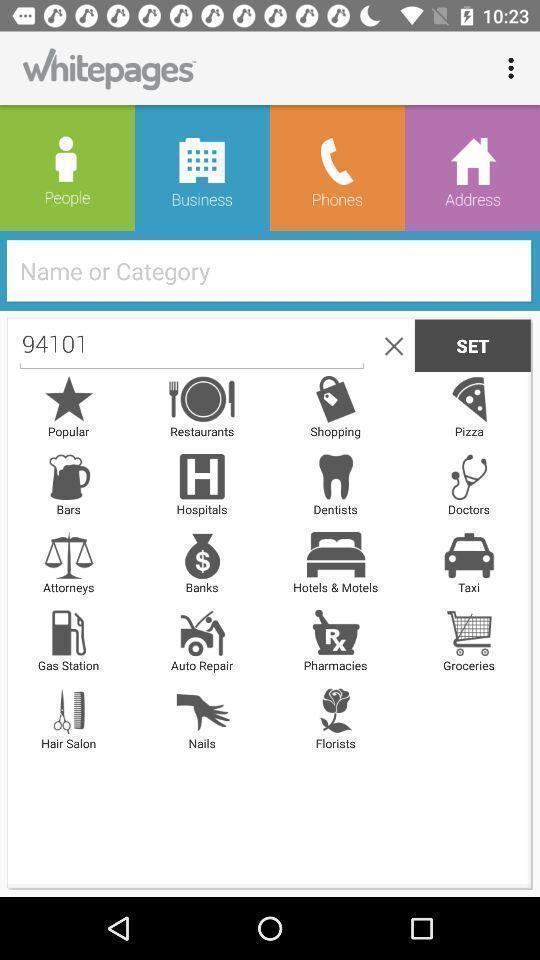Describe the key features of this screenshot. Screen displays different options for an app. 